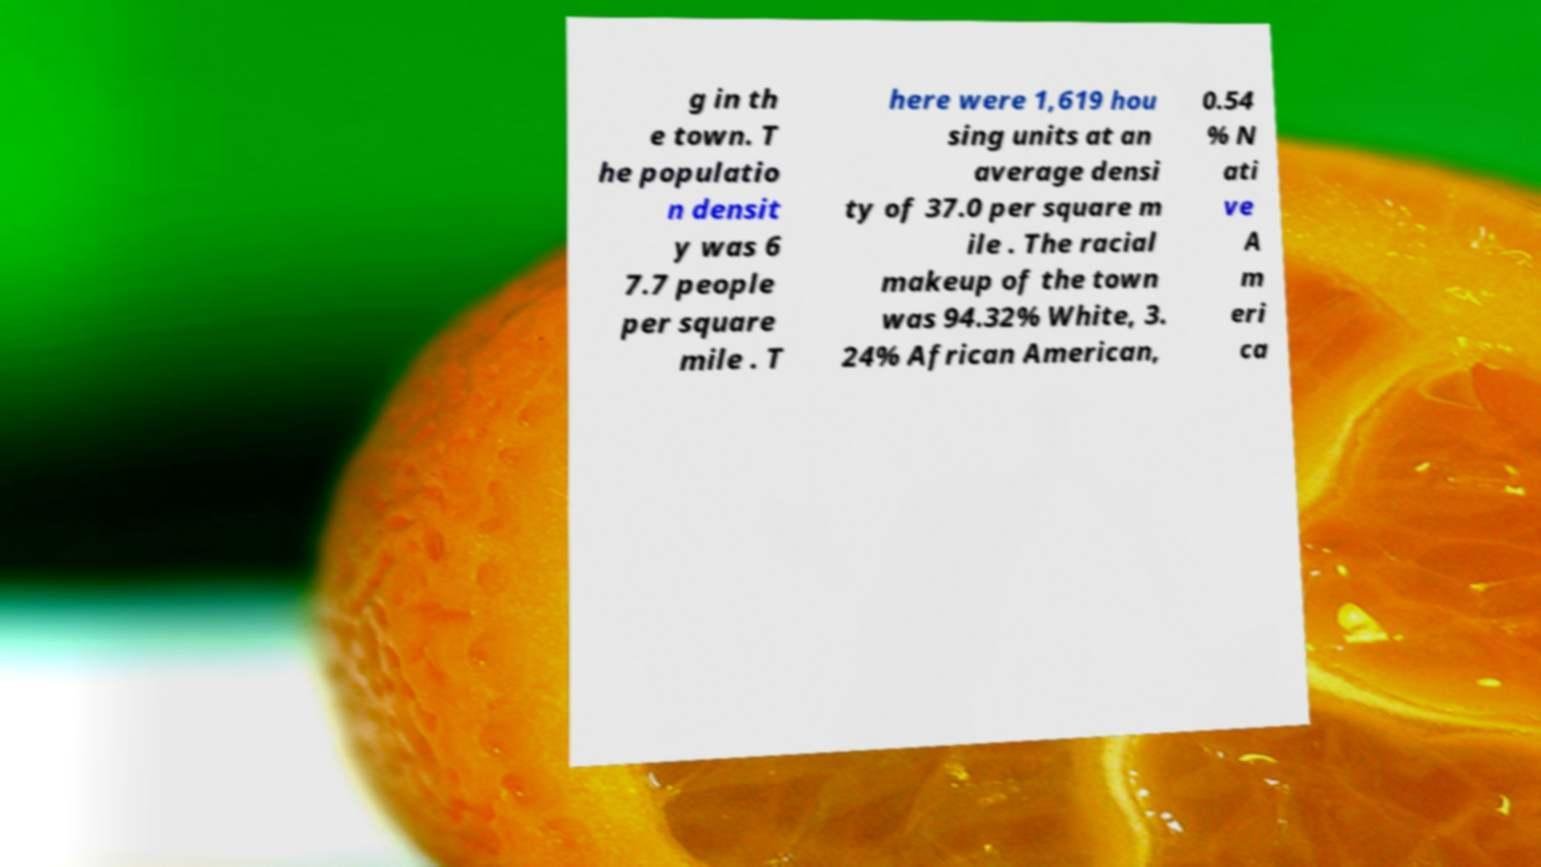I need the written content from this picture converted into text. Can you do that? g in th e town. T he populatio n densit y was 6 7.7 people per square mile . T here were 1,619 hou sing units at an average densi ty of 37.0 per square m ile . The racial makeup of the town was 94.32% White, 3. 24% African American, 0.54 % N ati ve A m eri ca 